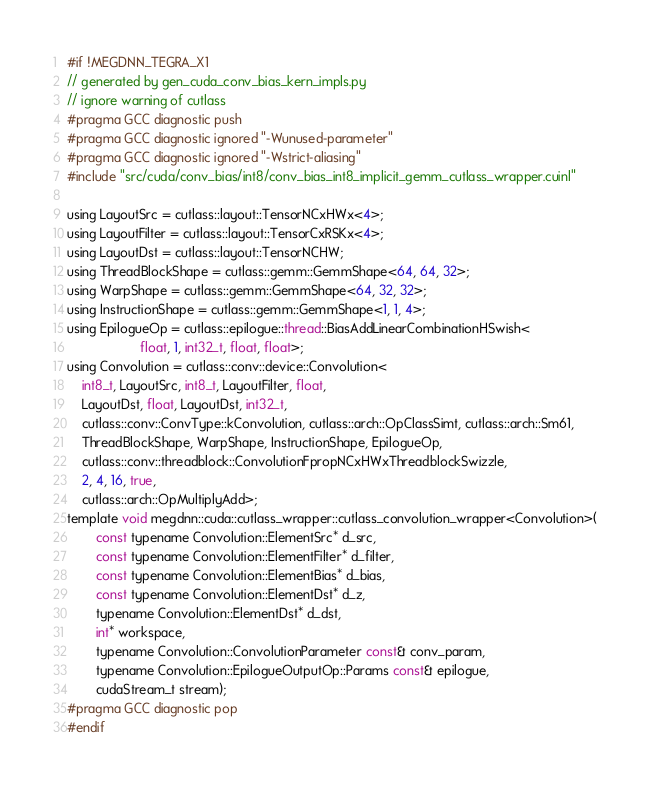<code> <loc_0><loc_0><loc_500><loc_500><_Cuda_>#if !MEGDNN_TEGRA_X1
// generated by gen_cuda_conv_bias_kern_impls.py
// ignore warning of cutlass
#pragma GCC diagnostic push
#pragma GCC diagnostic ignored "-Wunused-parameter"
#pragma GCC diagnostic ignored "-Wstrict-aliasing"
#include "src/cuda/conv_bias/int8/conv_bias_int8_implicit_gemm_cutlass_wrapper.cuinl"

using LayoutSrc = cutlass::layout::TensorNCxHWx<4>;
using LayoutFilter = cutlass::layout::TensorCxRSKx<4>;
using LayoutDst = cutlass::layout::TensorNCHW;
using ThreadBlockShape = cutlass::gemm::GemmShape<64, 64, 32>;
using WarpShape = cutlass::gemm::GemmShape<64, 32, 32>;
using InstructionShape = cutlass::gemm::GemmShape<1, 1, 4>;
using EpilogueOp = cutlass::epilogue::thread::BiasAddLinearCombinationHSwish<
                    float, 1, int32_t, float, float>;
using Convolution = cutlass::conv::device::Convolution<
    int8_t, LayoutSrc, int8_t, LayoutFilter, float, 
    LayoutDst, float, LayoutDst, int32_t, 
    cutlass::conv::ConvType::kConvolution, cutlass::arch::OpClassSimt, cutlass::arch::Sm61, 
    ThreadBlockShape, WarpShape, InstructionShape, EpilogueOp, 
    cutlass::conv::threadblock::ConvolutionFpropNCxHWxThreadblockSwizzle, 
    2, 4, 16, true, 
    cutlass::arch::OpMultiplyAdd>;
template void megdnn::cuda::cutlass_wrapper::cutlass_convolution_wrapper<Convolution>(
        const typename Convolution::ElementSrc* d_src, 
        const typename Convolution::ElementFilter* d_filter, 
        const typename Convolution::ElementBias* d_bias, 
        const typename Convolution::ElementDst* d_z, 
        typename Convolution::ElementDst* d_dst, 
        int* workspace, 
        typename Convolution::ConvolutionParameter const& conv_param, 
        typename Convolution::EpilogueOutputOp::Params const& epilogue, 
        cudaStream_t stream);
#pragma GCC diagnostic pop
#endif
</code> 